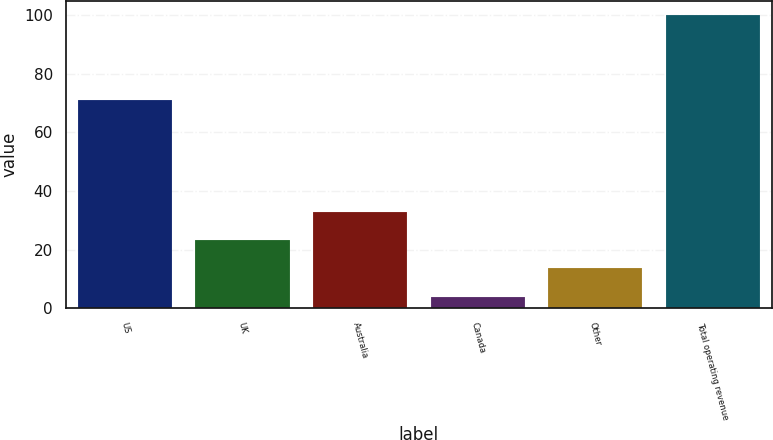Convert chart. <chart><loc_0><loc_0><loc_500><loc_500><bar_chart><fcel>US<fcel>UK<fcel>Australia<fcel>Canada<fcel>Other<fcel>Total operating revenue<nl><fcel>71<fcel>23.2<fcel>32.8<fcel>4<fcel>13.6<fcel>100<nl></chart> 